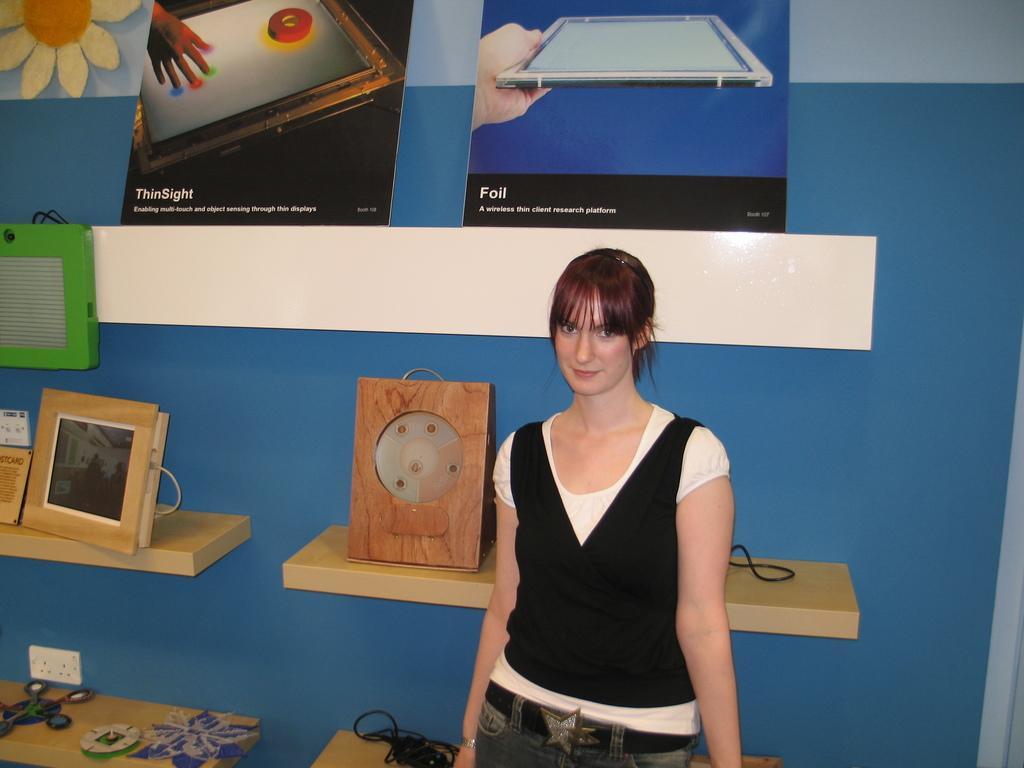Please provide a concise description of this image. In this image there is a woman standing. She is smiling. Behind her there is a wall. There are wooden shelves to the wall. There are boards, picture frames, cable wires and a few objects on the shelves. To the left there are switch boards on the wall. In the top left there is a picture of a flower on the wall. 